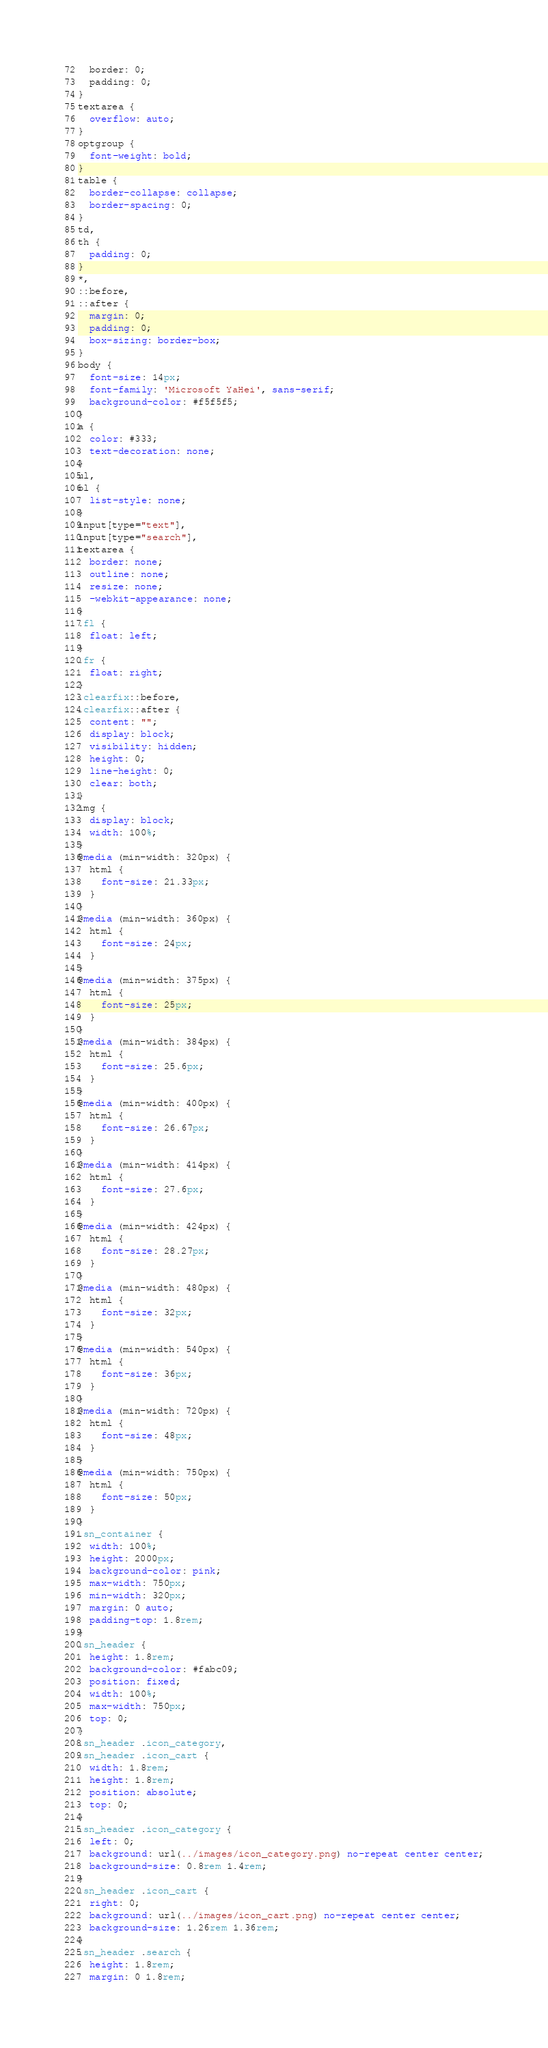<code> <loc_0><loc_0><loc_500><loc_500><_CSS_>  border: 0;
  padding: 0;
}
textarea {
  overflow: auto;
}
optgroup {
  font-weight: bold;
}
table {
  border-collapse: collapse;
  border-spacing: 0;
}
td,
th {
  padding: 0;
}
*,
::before,
::after {
  margin: 0;
  padding: 0;
  box-sizing: border-box;
}
body {
  font-size: 14px;
  font-family: 'Microsoft YaHei', sans-serif;
  background-color: #f5f5f5;
}
a {
  color: #333;
  text-decoration: none;
}
ul,
ol {
  list-style: none;
}
input[type="text"],
input[type="search"],
textarea {
  border: none;
  outline: none;
  resize: none;
  -webkit-appearance: none;
}
.fl {
  float: left;
}
.fr {
  float: right;
}
.clearfix::before,
.clearfix::after {
  content: "";
  display: block;
  visibility: hidden;
  height: 0;
  line-height: 0;
  clear: both;
}
img {
  display: block;
  width: 100%;
}
@media (min-width: 320px) {
  html {
    font-size: 21.33px;
  }
}
@media (min-width: 360px) {
  html {
    font-size: 24px;
  }
}
@media (min-width: 375px) {
  html {
    font-size: 25px;
  }
}
@media (min-width: 384px) {
  html {
    font-size: 25.6px;
  }
}
@media (min-width: 400px) {
  html {
    font-size: 26.67px;
  }
}
@media (min-width: 414px) {
  html {
    font-size: 27.6px;
  }
}
@media (min-width: 424px) {
  html {
    font-size: 28.27px;
  }
}
@media (min-width: 480px) {
  html {
    font-size: 32px;
  }
}
@media (min-width: 540px) {
  html {
    font-size: 36px;
  }
}
@media (min-width: 720px) {
  html {
    font-size: 48px;
  }
}
@media (min-width: 750px) {
  html {
    font-size: 50px;
  }
}
.sn_container {
  width: 100%;
  height: 2000px;
  background-color: pink;
  max-width: 750px;
  min-width: 320px;
  margin: 0 auto;
  padding-top: 1.8rem;
}
.sn_header {
  height: 1.8rem;
  background-color: #fabc09;
  position: fixed;
  width: 100%;
  max-width: 750px;
  top: 0;
}
.sn_header .icon_category,
.sn_header .icon_cart {
  width: 1.8rem;
  height: 1.8rem;
  position: absolute;
  top: 0;
}
.sn_header .icon_category {
  left: 0;
  background: url(../images/icon_category.png) no-repeat center center;
  background-size: 0.8rem 1.4rem;
}
.sn_header .icon_cart {
  right: 0;
  background: url(../images/icon_cart.png) no-repeat center center;
  background-size: 1.26rem 1.36rem;
}
.sn_header .search {
  height: 1.8rem;
  margin: 0 1.8rem;</code> 